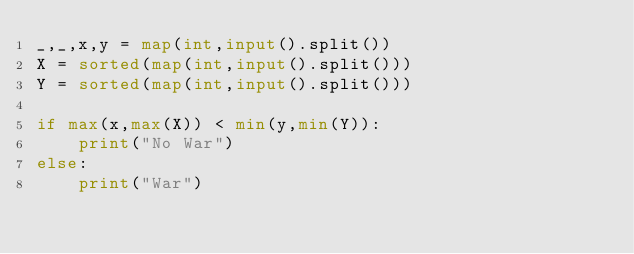Convert code to text. <code><loc_0><loc_0><loc_500><loc_500><_Python_>_,_,x,y = map(int,input().split())
X = sorted(map(int,input().split()))
Y = sorted(map(int,input().split()))

if max(x,max(X)) < min(y,min(Y)):
    print("No War")
else:
    print("War")</code> 